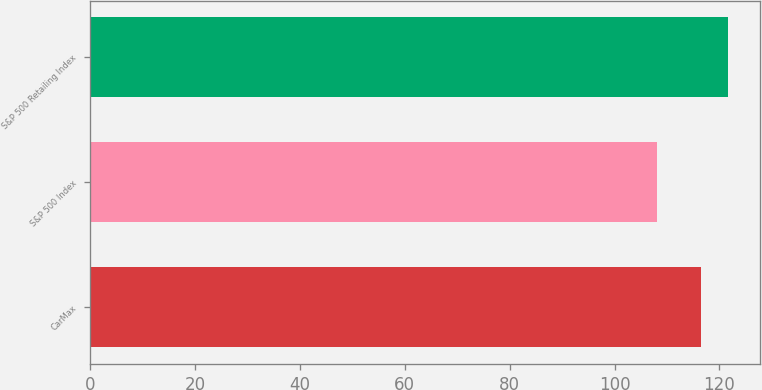<chart> <loc_0><loc_0><loc_500><loc_500><bar_chart><fcel>CarMax<fcel>S&P 500 Index<fcel>S&P 500 Retailing Index<nl><fcel>116.49<fcel>108.12<fcel>121.71<nl></chart> 